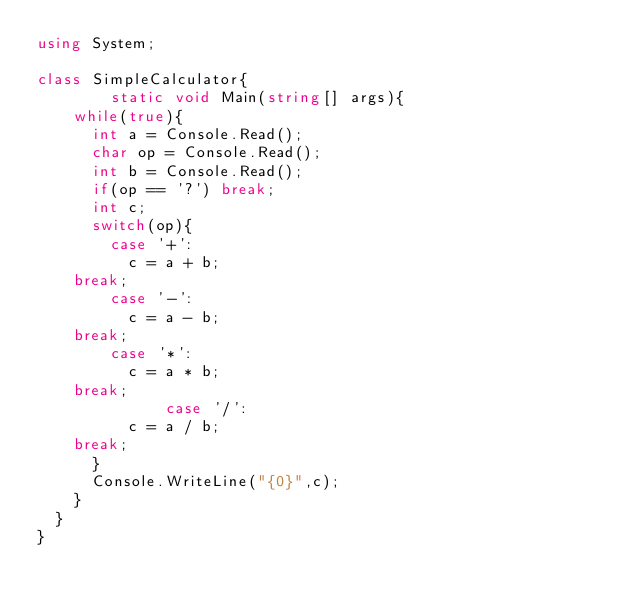Convert code to text. <code><loc_0><loc_0><loc_500><loc_500><_C#_>using System;

class SimpleCalculator{
        static void Main(string[] args){
	  while(true){
	    int a = Console.Read();
	    char op = Console.Read();
	    int b = Console.Read();
	    if(op == '?') break;
	    int c;
	    switch(op){
	      case '+':
	        c = a + b;
		break;
	      case '-':
	        c = a - b;
		break;
	      case '*':
	        c = a * b;
		break;
              case '/':
	        c = a / b;
		break;
	    }
	    Console.WriteLine("{0}",c);
	  }
	}
}</code> 